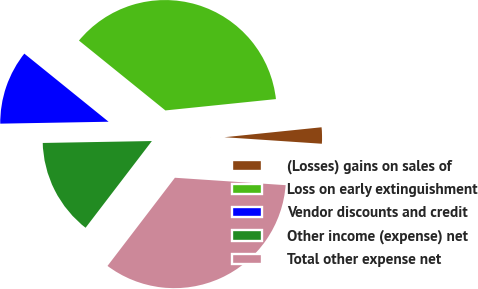Convert chart. <chart><loc_0><loc_0><loc_500><loc_500><pie_chart><fcel>(Losses) gains on sales of<fcel>Loss on early extinguishment<fcel>Vendor discounts and credit<fcel>Other income (expense) net<fcel>Total other expense net<nl><fcel>2.69%<fcel>37.55%<fcel>11.1%<fcel>14.33%<fcel>34.32%<nl></chart> 